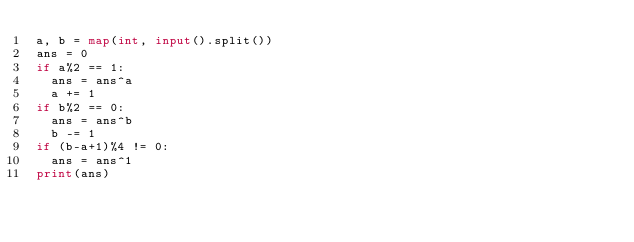<code> <loc_0><loc_0><loc_500><loc_500><_Python_>a, b = map(int, input().split())
ans = 0
if a%2 == 1:
  ans = ans^a
  a += 1
if b%2 == 0:
  ans = ans^b
  b -= 1
if (b-a+1)%4 != 0:
  ans = ans^1
print(ans)</code> 